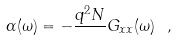Convert formula to latex. <formula><loc_0><loc_0><loc_500><loc_500>\alpha ( \omega ) = - \frac { q ^ { 2 } N } { } G _ { x x } ( \omega ) \ ,</formula> 